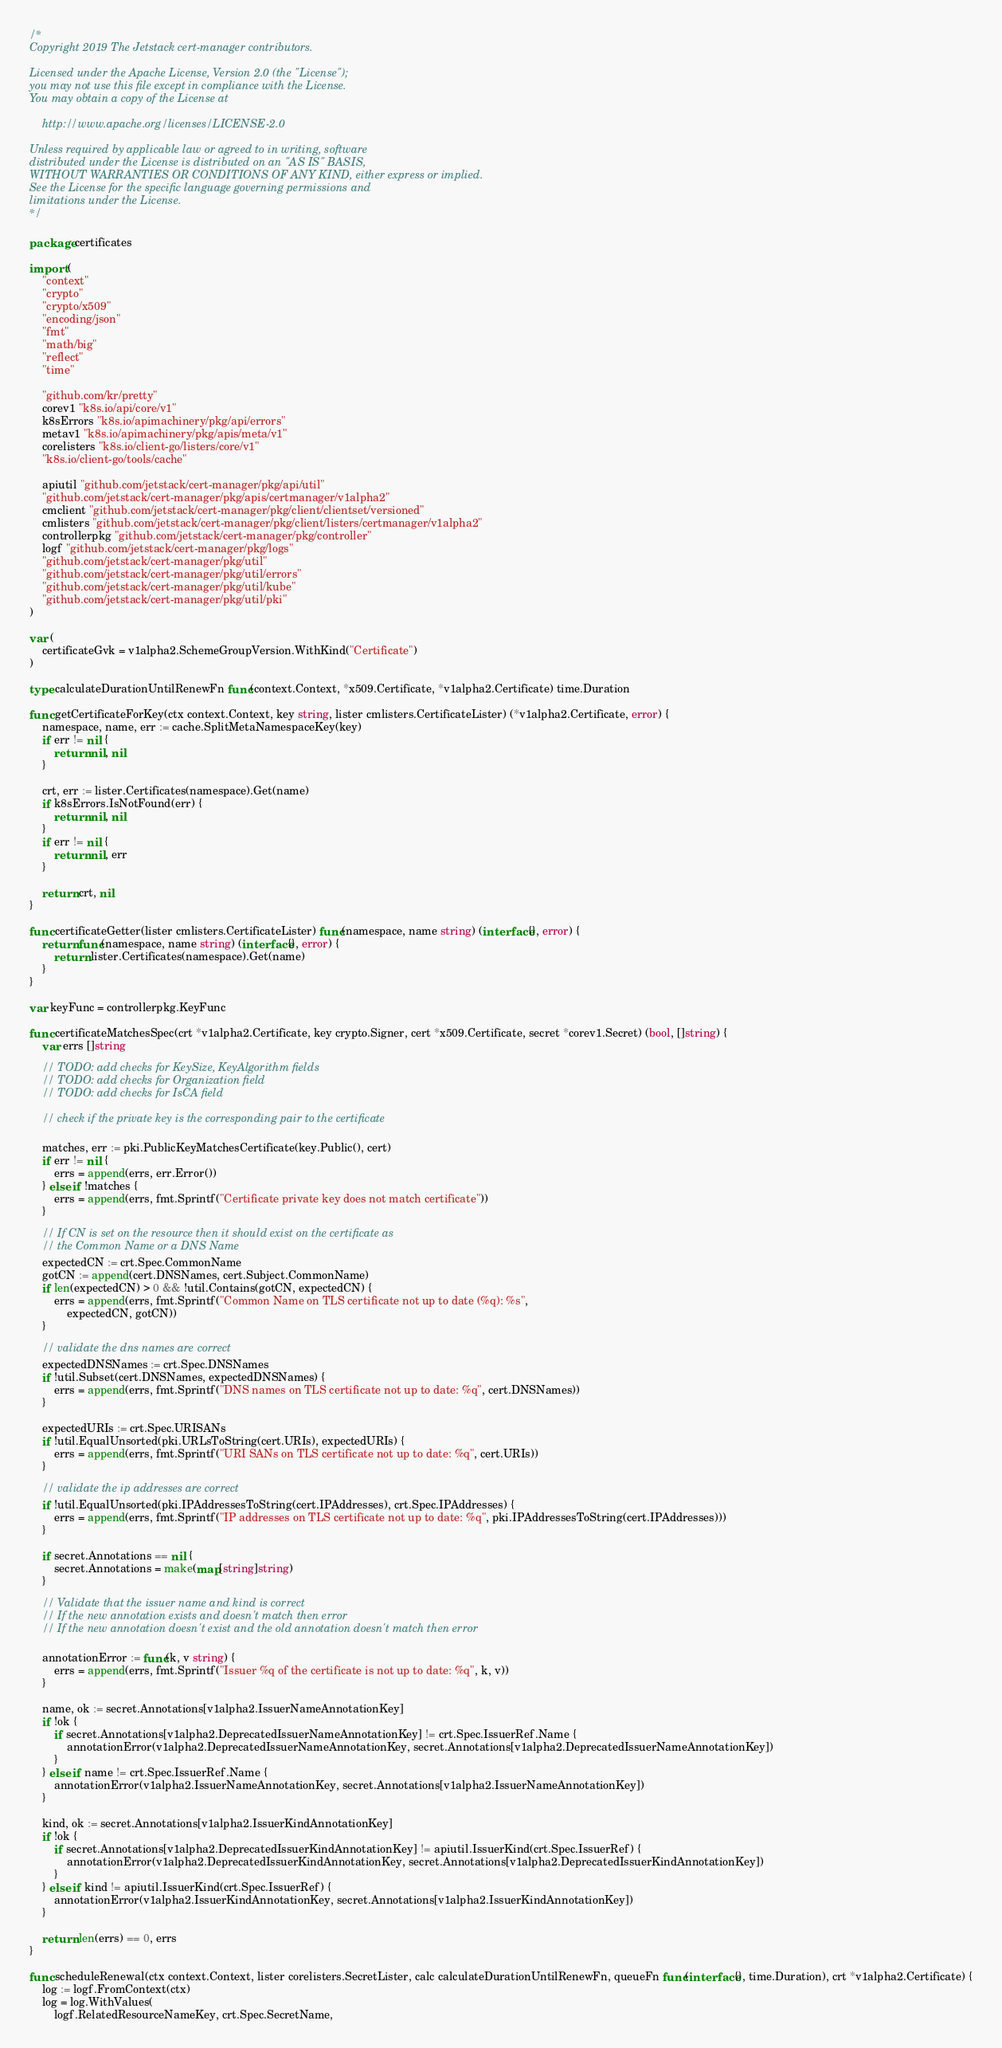Convert code to text. <code><loc_0><loc_0><loc_500><loc_500><_Go_>/*
Copyright 2019 The Jetstack cert-manager contributors.

Licensed under the Apache License, Version 2.0 (the "License");
you may not use this file except in compliance with the License.
You may obtain a copy of the License at

    http://www.apache.org/licenses/LICENSE-2.0

Unless required by applicable law or agreed to in writing, software
distributed under the License is distributed on an "AS IS" BASIS,
WITHOUT WARRANTIES OR CONDITIONS OF ANY KIND, either express or implied.
See the License for the specific language governing permissions and
limitations under the License.
*/

package certificates

import (
	"context"
	"crypto"
	"crypto/x509"
	"encoding/json"
	"fmt"
	"math/big"
	"reflect"
	"time"

	"github.com/kr/pretty"
	corev1 "k8s.io/api/core/v1"
	k8sErrors "k8s.io/apimachinery/pkg/api/errors"
	metav1 "k8s.io/apimachinery/pkg/apis/meta/v1"
	corelisters "k8s.io/client-go/listers/core/v1"
	"k8s.io/client-go/tools/cache"

	apiutil "github.com/jetstack/cert-manager/pkg/api/util"
	"github.com/jetstack/cert-manager/pkg/apis/certmanager/v1alpha2"
	cmclient "github.com/jetstack/cert-manager/pkg/client/clientset/versioned"
	cmlisters "github.com/jetstack/cert-manager/pkg/client/listers/certmanager/v1alpha2"
	controllerpkg "github.com/jetstack/cert-manager/pkg/controller"
	logf "github.com/jetstack/cert-manager/pkg/logs"
	"github.com/jetstack/cert-manager/pkg/util"
	"github.com/jetstack/cert-manager/pkg/util/errors"
	"github.com/jetstack/cert-manager/pkg/util/kube"
	"github.com/jetstack/cert-manager/pkg/util/pki"
)

var (
	certificateGvk = v1alpha2.SchemeGroupVersion.WithKind("Certificate")
)

type calculateDurationUntilRenewFn func(context.Context, *x509.Certificate, *v1alpha2.Certificate) time.Duration

func getCertificateForKey(ctx context.Context, key string, lister cmlisters.CertificateLister) (*v1alpha2.Certificate, error) {
	namespace, name, err := cache.SplitMetaNamespaceKey(key)
	if err != nil {
		return nil, nil
	}

	crt, err := lister.Certificates(namespace).Get(name)
	if k8sErrors.IsNotFound(err) {
		return nil, nil
	}
	if err != nil {
		return nil, err
	}

	return crt, nil
}

func certificateGetter(lister cmlisters.CertificateLister) func(namespace, name string) (interface{}, error) {
	return func(namespace, name string) (interface{}, error) {
		return lister.Certificates(namespace).Get(name)
	}
}

var keyFunc = controllerpkg.KeyFunc

func certificateMatchesSpec(crt *v1alpha2.Certificate, key crypto.Signer, cert *x509.Certificate, secret *corev1.Secret) (bool, []string) {
	var errs []string

	// TODO: add checks for KeySize, KeyAlgorithm fields
	// TODO: add checks for Organization field
	// TODO: add checks for IsCA field

	// check if the private key is the corresponding pair to the certificate

	matches, err := pki.PublicKeyMatchesCertificate(key.Public(), cert)
	if err != nil {
		errs = append(errs, err.Error())
	} else if !matches {
		errs = append(errs, fmt.Sprintf("Certificate private key does not match certificate"))
	}

	// If CN is set on the resource then it should exist on the certificate as
	// the Common Name or a DNS Name
	expectedCN := crt.Spec.CommonName
	gotCN := append(cert.DNSNames, cert.Subject.CommonName)
	if len(expectedCN) > 0 && !util.Contains(gotCN, expectedCN) {
		errs = append(errs, fmt.Sprintf("Common Name on TLS certificate not up to date (%q): %s",
			expectedCN, gotCN))
	}

	// validate the dns names are correct
	expectedDNSNames := crt.Spec.DNSNames
	if !util.Subset(cert.DNSNames, expectedDNSNames) {
		errs = append(errs, fmt.Sprintf("DNS names on TLS certificate not up to date: %q", cert.DNSNames))
	}

	expectedURIs := crt.Spec.URISANs
	if !util.EqualUnsorted(pki.URLsToString(cert.URIs), expectedURIs) {
		errs = append(errs, fmt.Sprintf("URI SANs on TLS certificate not up to date: %q", cert.URIs))
	}

	// validate the ip addresses are correct
	if !util.EqualUnsorted(pki.IPAddressesToString(cert.IPAddresses), crt.Spec.IPAddresses) {
		errs = append(errs, fmt.Sprintf("IP addresses on TLS certificate not up to date: %q", pki.IPAddressesToString(cert.IPAddresses)))
	}

	if secret.Annotations == nil {
		secret.Annotations = make(map[string]string)
	}

	// Validate that the issuer name and kind is correct
	// If the new annotation exists and doesn't match then error
	// If the new annotation doesn't exist and the old annotation doesn't match then error

	annotationError := func(k, v string) {
		errs = append(errs, fmt.Sprintf("Issuer %q of the certificate is not up to date: %q", k, v))
	}

	name, ok := secret.Annotations[v1alpha2.IssuerNameAnnotationKey]
	if !ok {
		if secret.Annotations[v1alpha2.DeprecatedIssuerNameAnnotationKey] != crt.Spec.IssuerRef.Name {
			annotationError(v1alpha2.DeprecatedIssuerNameAnnotationKey, secret.Annotations[v1alpha2.DeprecatedIssuerNameAnnotationKey])
		}
	} else if name != crt.Spec.IssuerRef.Name {
		annotationError(v1alpha2.IssuerNameAnnotationKey, secret.Annotations[v1alpha2.IssuerNameAnnotationKey])
	}

	kind, ok := secret.Annotations[v1alpha2.IssuerKindAnnotationKey]
	if !ok {
		if secret.Annotations[v1alpha2.DeprecatedIssuerKindAnnotationKey] != apiutil.IssuerKind(crt.Spec.IssuerRef) {
			annotationError(v1alpha2.DeprecatedIssuerKindAnnotationKey, secret.Annotations[v1alpha2.DeprecatedIssuerKindAnnotationKey])
		}
	} else if kind != apiutil.IssuerKind(crt.Spec.IssuerRef) {
		annotationError(v1alpha2.IssuerKindAnnotationKey, secret.Annotations[v1alpha2.IssuerKindAnnotationKey])
	}

	return len(errs) == 0, errs
}

func scheduleRenewal(ctx context.Context, lister corelisters.SecretLister, calc calculateDurationUntilRenewFn, queueFn func(interface{}, time.Duration), crt *v1alpha2.Certificate) {
	log := logf.FromContext(ctx)
	log = log.WithValues(
		logf.RelatedResourceNameKey, crt.Spec.SecretName,</code> 